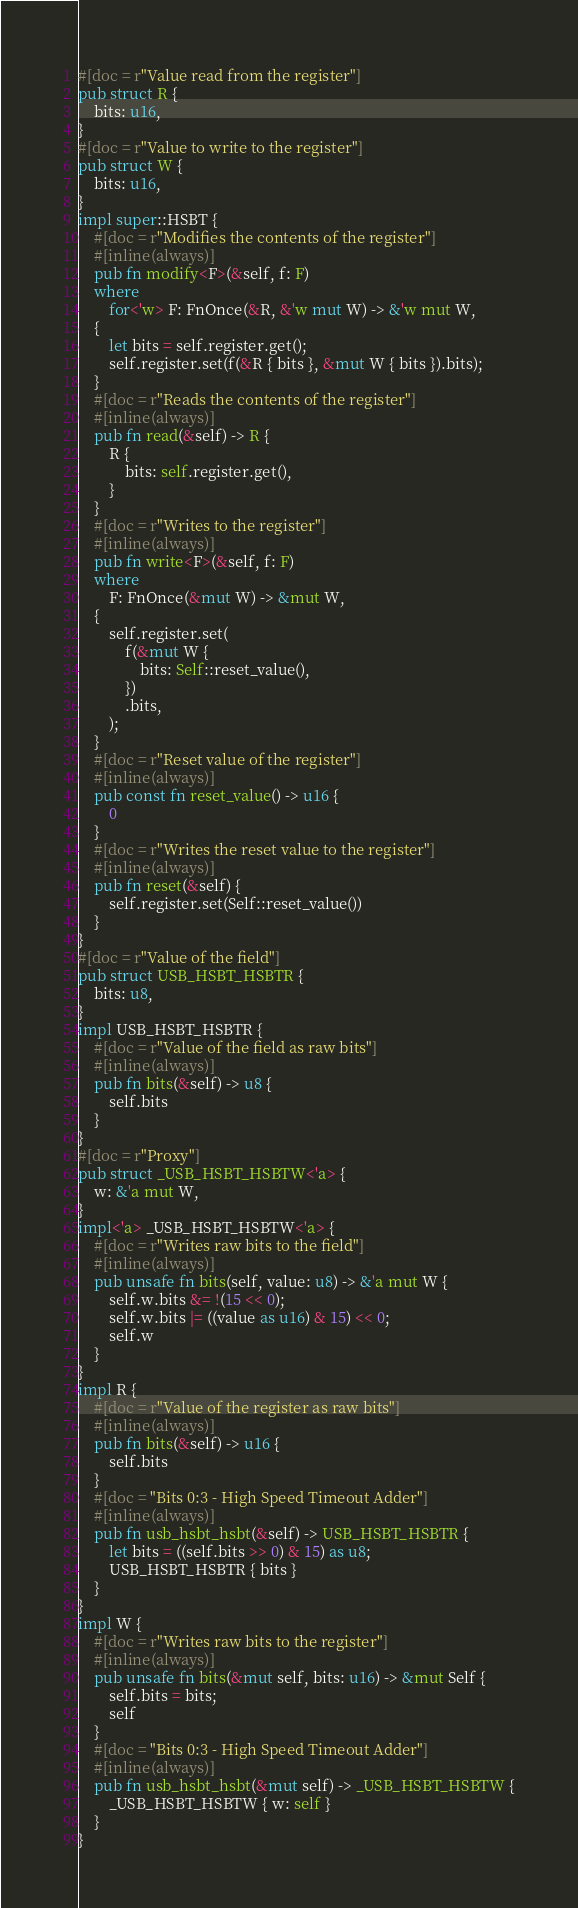<code> <loc_0><loc_0><loc_500><loc_500><_Rust_>#[doc = r"Value read from the register"]
pub struct R {
    bits: u16,
}
#[doc = r"Value to write to the register"]
pub struct W {
    bits: u16,
}
impl super::HSBT {
    #[doc = r"Modifies the contents of the register"]
    #[inline(always)]
    pub fn modify<F>(&self, f: F)
    where
        for<'w> F: FnOnce(&R, &'w mut W) -> &'w mut W,
    {
        let bits = self.register.get();
        self.register.set(f(&R { bits }, &mut W { bits }).bits);
    }
    #[doc = r"Reads the contents of the register"]
    #[inline(always)]
    pub fn read(&self) -> R {
        R {
            bits: self.register.get(),
        }
    }
    #[doc = r"Writes to the register"]
    #[inline(always)]
    pub fn write<F>(&self, f: F)
    where
        F: FnOnce(&mut W) -> &mut W,
    {
        self.register.set(
            f(&mut W {
                bits: Self::reset_value(),
            })
            .bits,
        );
    }
    #[doc = r"Reset value of the register"]
    #[inline(always)]
    pub const fn reset_value() -> u16 {
        0
    }
    #[doc = r"Writes the reset value to the register"]
    #[inline(always)]
    pub fn reset(&self) {
        self.register.set(Self::reset_value())
    }
}
#[doc = r"Value of the field"]
pub struct USB_HSBT_HSBTR {
    bits: u8,
}
impl USB_HSBT_HSBTR {
    #[doc = r"Value of the field as raw bits"]
    #[inline(always)]
    pub fn bits(&self) -> u8 {
        self.bits
    }
}
#[doc = r"Proxy"]
pub struct _USB_HSBT_HSBTW<'a> {
    w: &'a mut W,
}
impl<'a> _USB_HSBT_HSBTW<'a> {
    #[doc = r"Writes raw bits to the field"]
    #[inline(always)]
    pub unsafe fn bits(self, value: u8) -> &'a mut W {
        self.w.bits &= !(15 << 0);
        self.w.bits |= ((value as u16) & 15) << 0;
        self.w
    }
}
impl R {
    #[doc = r"Value of the register as raw bits"]
    #[inline(always)]
    pub fn bits(&self) -> u16 {
        self.bits
    }
    #[doc = "Bits 0:3 - High Speed Timeout Adder"]
    #[inline(always)]
    pub fn usb_hsbt_hsbt(&self) -> USB_HSBT_HSBTR {
        let bits = ((self.bits >> 0) & 15) as u8;
        USB_HSBT_HSBTR { bits }
    }
}
impl W {
    #[doc = r"Writes raw bits to the register"]
    #[inline(always)]
    pub unsafe fn bits(&mut self, bits: u16) -> &mut Self {
        self.bits = bits;
        self
    }
    #[doc = "Bits 0:3 - High Speed Timeout Adder"]
    #[inline(always)]
    pub fn usb_hsbt_hsbt(&mut self) -> _USB_HSBT_HSBTW {
        _USB_HSBT_HSBTW { w: self }
    }
}
</code> 